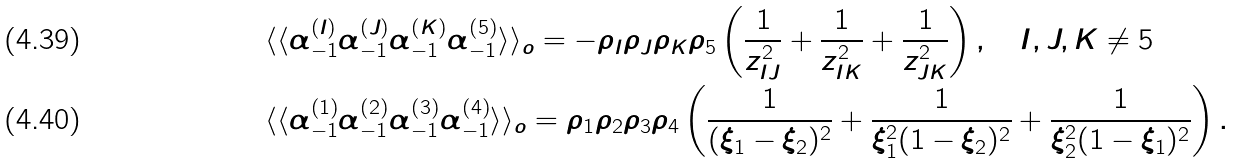Convert formula to latex. <formula><loc_0><loc_0><loc_500><loc_500>& \langle \langle \alpha _ { - 1 } ^ { ( I ) } \alpha _ { - 1 } ^ { ( J ) } \alpha _ { - 1 } ^ { ( K ) } \alpha _ { - 1 } ^ { ( 5 ) } \rangle \rangle _ { o } = - \rho _ { I } \rho _ { J } \rho _ { K } \rho _ { 5 } \left ( \frac { 1 } { z _ { I J } ^ { 2 } } + \frac { 1 } { z _ { I K } ^ { 2 } } + \frac { 1 } { z _ { J K } ^ { 2 } } \right ) , \quad I , J , K \neq 5 \\ & \langle \langle \alpha _ { - 1 } ^ { ( 1 ) } \alpha _ { - 1 } ^ { ( 2 ) } \alpha _ { - 1 } ^ { ( 3 ) } \alpha _ { - 1 } ^ { ( 4 ) } \rangle \rangle _ { o } = \rho _ { 1 } \rho _ { 2 } \rho _ { 3 } \rho _ { 4 } \left ( \frac { 1 } { ( \xi _ { 1 } - \xi _ { 2 } ) ^ { 2 } } + \frac { 1 } { \xi _ { 1 } ^ { 2 } ( 1 - \xi _ { 2 } ) ^ { 2 } } + \frac { 1 } { \xi _ { 2 } ^ { 2 } ( 1 - \xi _ { 1 } ) ^ { 2 } } \right ) .</formula> 